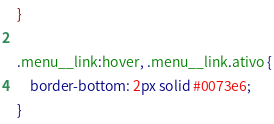Convert code to text. <code><loc_0><loc_0><loc_500><loc_500><_CSS_>}

.menu__link:hover, .menu__link.ativo {
    border-bottom: 2px solid #0073e6;
}</code> 